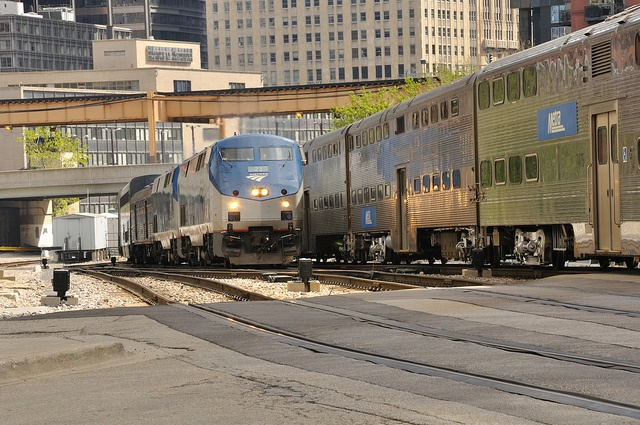Describe the objects in this image and their specific colors. I can see train in darkgray, gray, and black tones and train in darkgray, black, and gray tones in this image. 